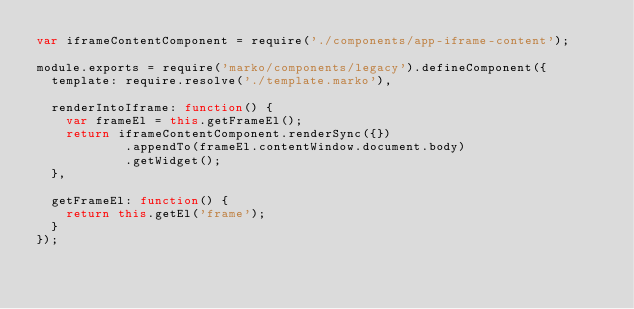Convert code to text. <code><loc_0><loc_0><loc_500><loc_500><_JavaScript_>var iframeContentComponent = require('./components/app-iframe-content');

module.exports = require('marko/components/legacy').defineComponent({
	template: require.resolve('./template.marko'),

	renderIntoIframe: function() {
		var frameEl = this.getFrameEl();
		return iframeContentComponent.renderSync({})
            .appendTo(frameEl.contentWindow.document.body)
            .getWidget();
	},

	getFrameEl: function() {
		return this.getEl('frame');
	}
});</code> 